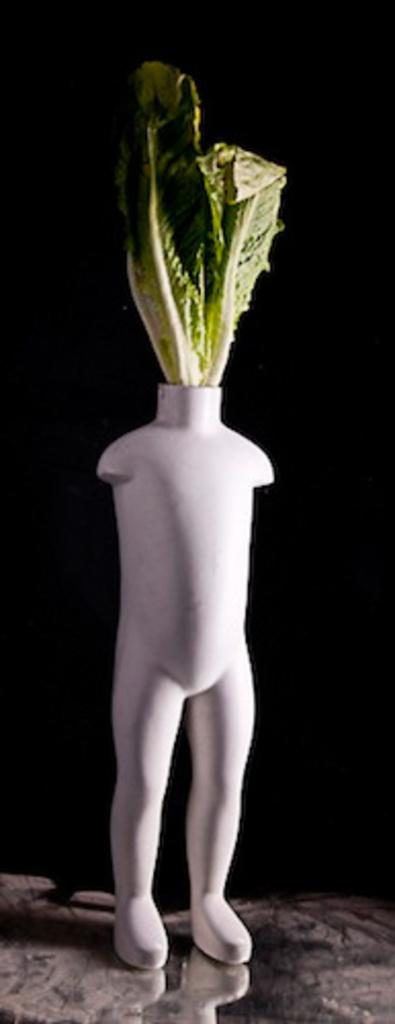What is the main subject of the image? There is an object in the image that resembles a person. What is the material of the object? The object contains leaves. What is the surface on which the object is placed? There is a floor at the bottom of the image. How would you describe the lighting in the image? The background of the image is dark. How many cakes are being served by the frog in the image? There is no frog or cakes present in the image. 